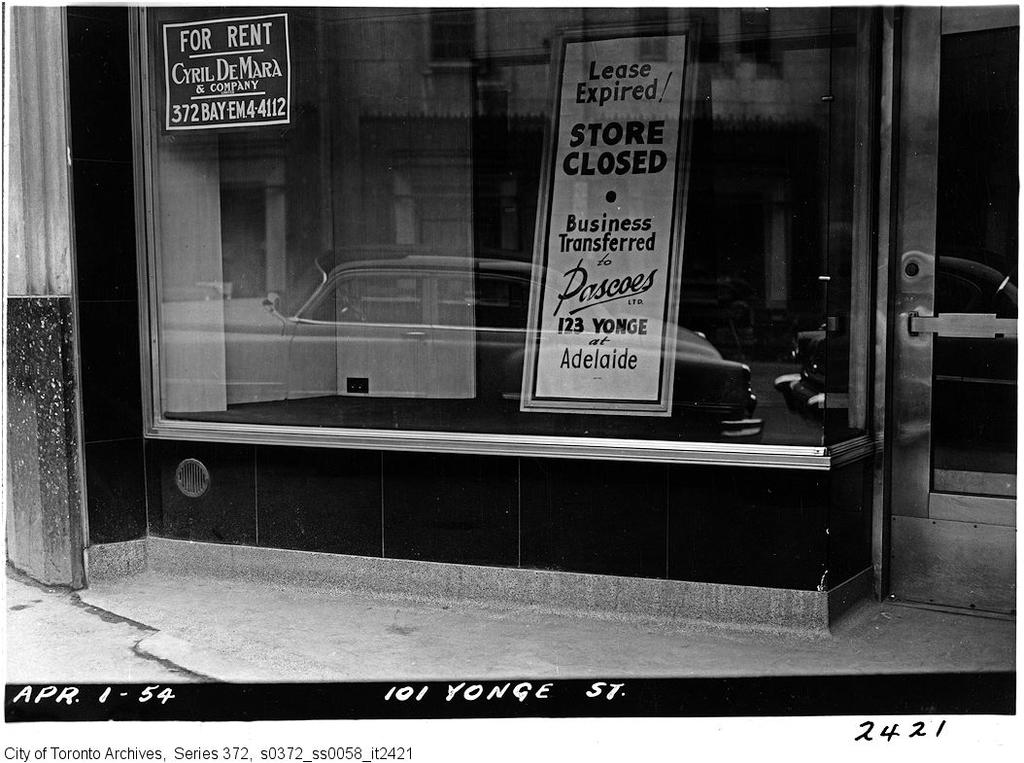What type of establishment is shown in the image? The image depicts a shop or a restaurant. What can be seen in front of the establishment? There are boards visible in the front of the shop or restaurant. Where is the entrance to the establishment located? There is a door on the right side of the image. What is visible at the bottom of the image? A road is present at the bottom of the image. What type of chalk is being used to write on the boards in the image? There is no chalk visible in the image, and no writing is shown on the boards. What view can be seen from the establishment in the image? The image does not show the view from the establishment, only the exterior of the building. 